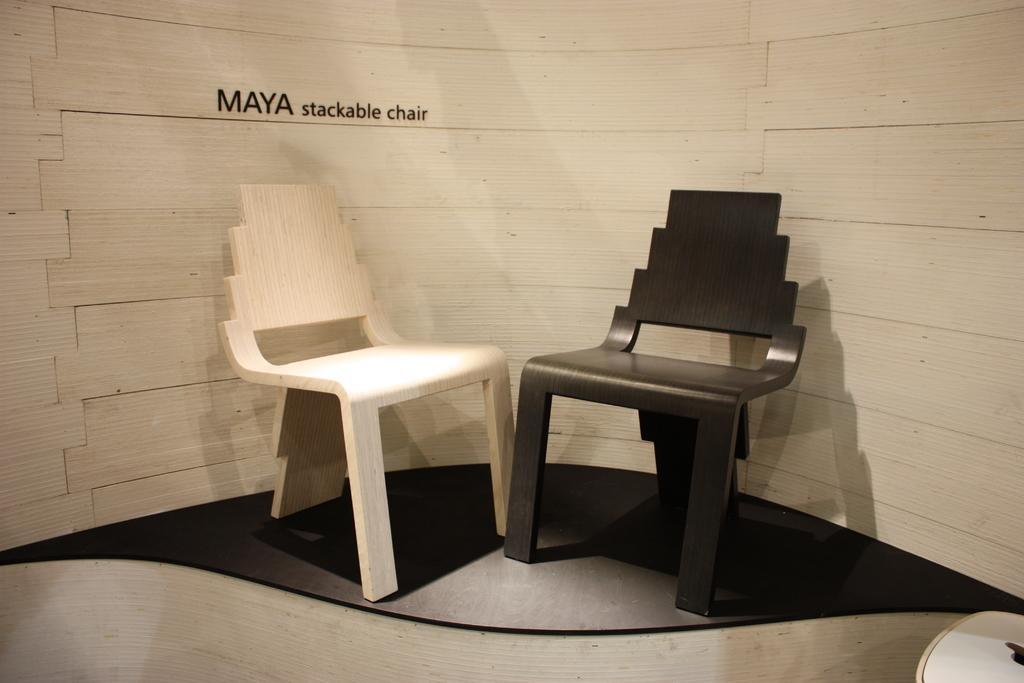Can you describe this image briefly? This image consists of two chairs made up of wood. There are in black and white color. In the background, there is a wall made up of wood. At the bottom, there is a floor. 